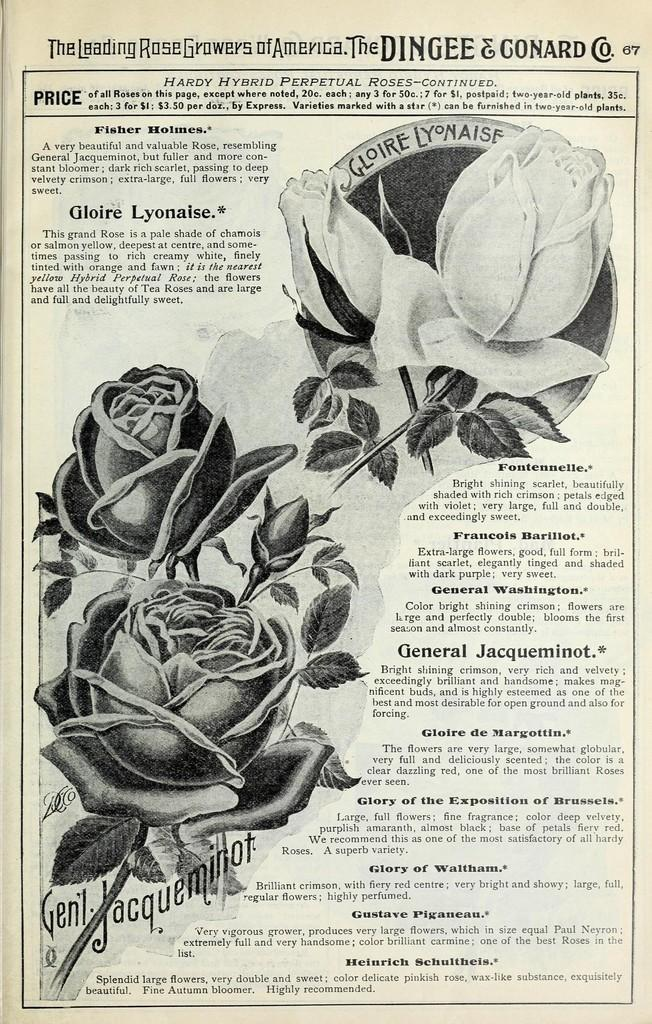What is present on the paper in the image? The paper contains words, numbers, and photos of roses. Can you describe the content of the paper in more detail? The paper contains words and numbers, as well as photos of roses. What type of salt is sprinkled around the edges of the paper in the image? There is no salt present in the image; it only contains a paper with words, numbers, and photos of roses. 